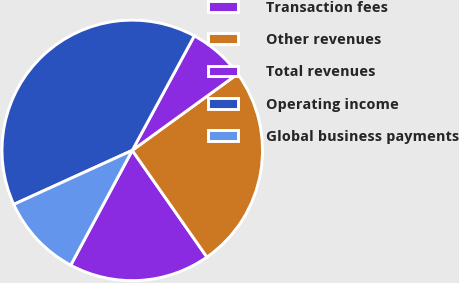Convert chart to OTSL. <chart><loc_0><loc_0><loc_500><loc_500><pie_chart><fcel>Transaction fees<fcel>Other revenues<fcel>Total revenues<fcel>Operating income<fcel>Global business payments<nl><fcel>17.55%<fcel>25.27%<fcel>7.11%<fcel>39.71%<fcel>10.36%<nl></chart> 